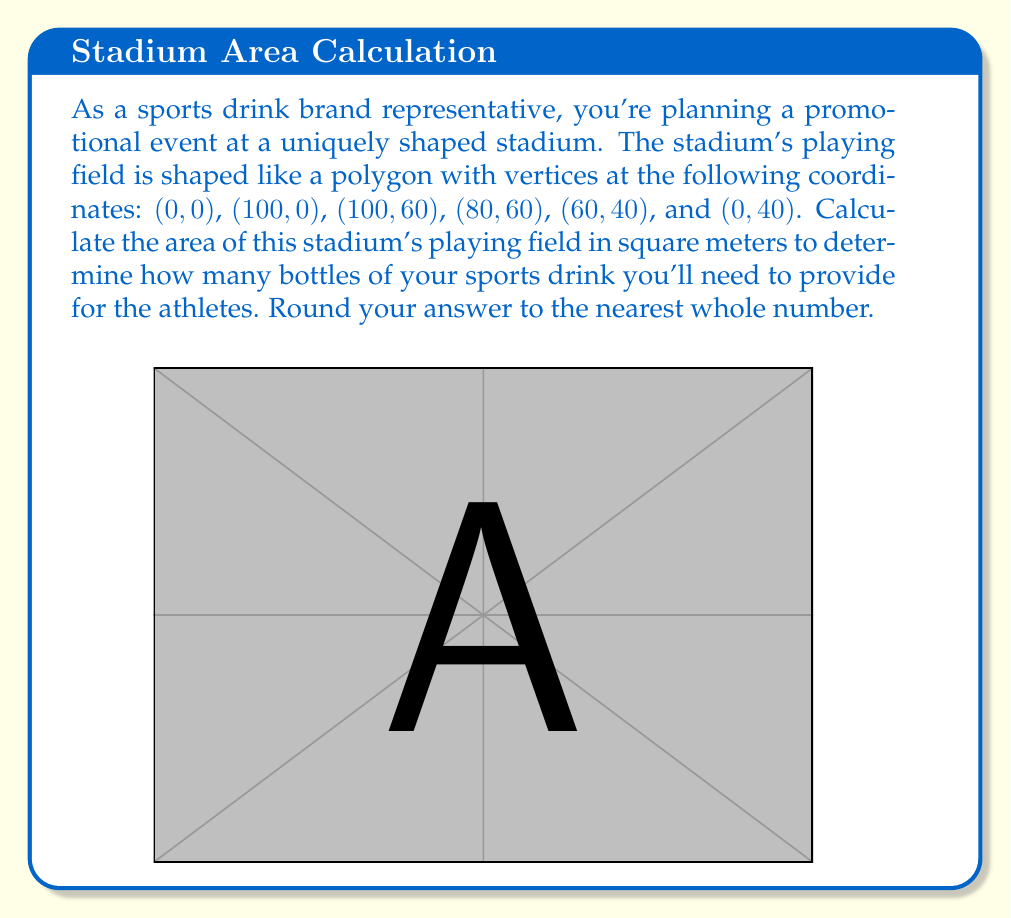Could you help me with this problem? To solve this problem, we'll use the shoelace formula (also known as the surveyor's formula) to calculate the area of the polygon. The steps are as follows:

1) The shoelace formula for a polygon with n vertices $(x_1, y_1), (x_2, y_2), ..., (x_n, y_n)$ is:

   $$Area = \frac{1}{2}|(x_1y_2 + x_2y_3 + ... + x_ny_1) - (y_1x_2 + y_2x_3 + ... + y_nx_1)|$$

2) Let's arrange our vertices in order:
   $(x_1, y_1) = (0, 0)$
   $(x_2, y_2) = (100, 0)$
   $(x_3, y_3) = (100, 60)$
   $(x_4, y_4) = (80, 60)$
   $(x_5, y_5) = (60, 40)$
   $(x_6, y_6) = (0, 40)$

3) Now, let's apply the formula:

   $$\begin{align*}
   Area &= \frac{1}{2}|(0 \cdot 0 + 100 \cdot 60 + 100 \cdot 60 + 80 \cdot 40 + 60 \cdot 40 + 0 \cdot 0) \\
   &\quad - (0 \cdot 100 + 0 \cdot 100 + 60 \cdot 80 + 60 \cdot 60 + 40 \cdot 0 + 40 \cdot 0)|
   \end{align*}$$

4) Simplify:
   
   $$\begin{align*}
   Area &= \frac{1}{2}|(6000 + 6000 + 3200 + 2400) - (4800 + 3600)| \\
   &= \frac{1}{2}|17600 - 8400| \\
   &= \frac{1}{2}|9200| \\
   &= 4600
   \end{align*}$$

5) Therefore, the area of the stadium's playing field is 4600 square meters.
Answer: 4600 square meters 